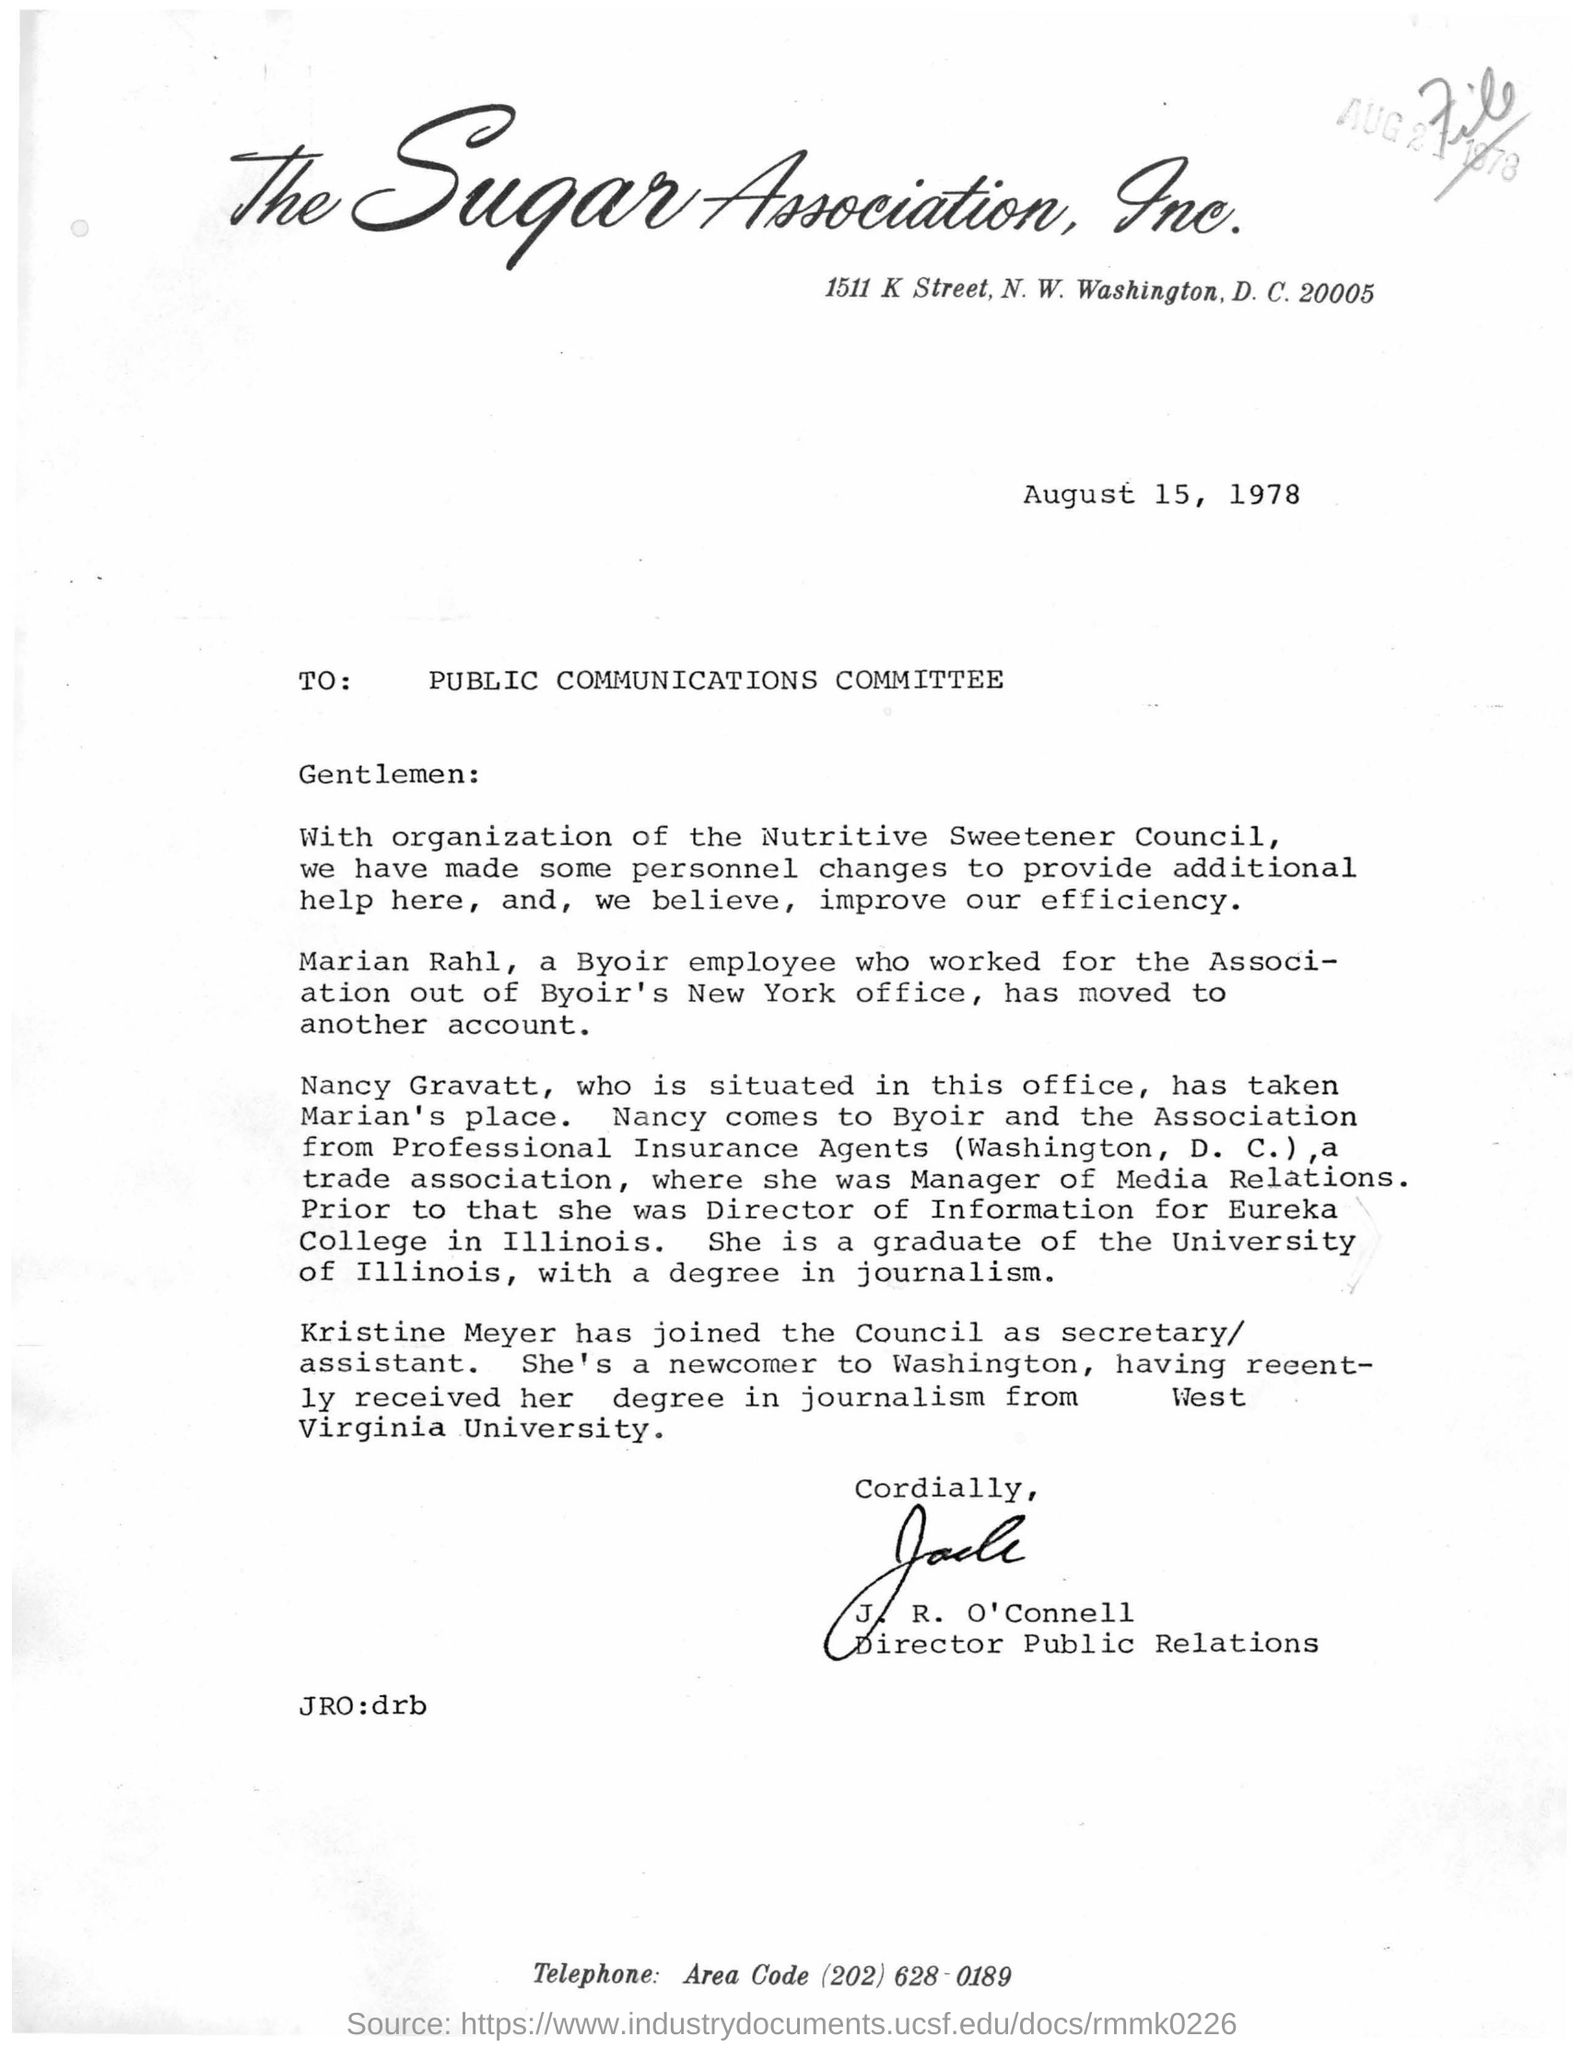What is the date mentioned in the given page ?
Provide a short and direct response. August 15, 1978. To whom the letter was written ?
Provide a short and direct response. Public communications committee. Who's sign was there at the bottom of the letter ?
Give a very brief answer. J. R. O'Connell. What is the designation of j.r. o'connell ?
Give a very brief answer. Director Public relations. 